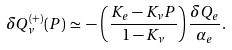Convert formula to latex. <formula><loc_0><loc_0><loc_500><loc_500>\delta Q _ { \nu } ^ { ( + ) } ( P ) \, \simeq \, - \, \left ( \frac { K _ { e } - K _ { \nu } P } { 1 - K _ { \nu } } \right ) \frac { \delta Q _ { e } } { \alpha _ { e } } .</formula> 